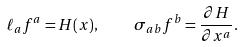Convert formula to latex. <formula><loc_0><loc_0><loc_500><loc_500>\ell _ { a } f ^ { a } = H ( x ) , \quad \sigma _ { a b } f ^ { b } = \frac { \partial H } { \partial x ^ { a } } .</formula> 